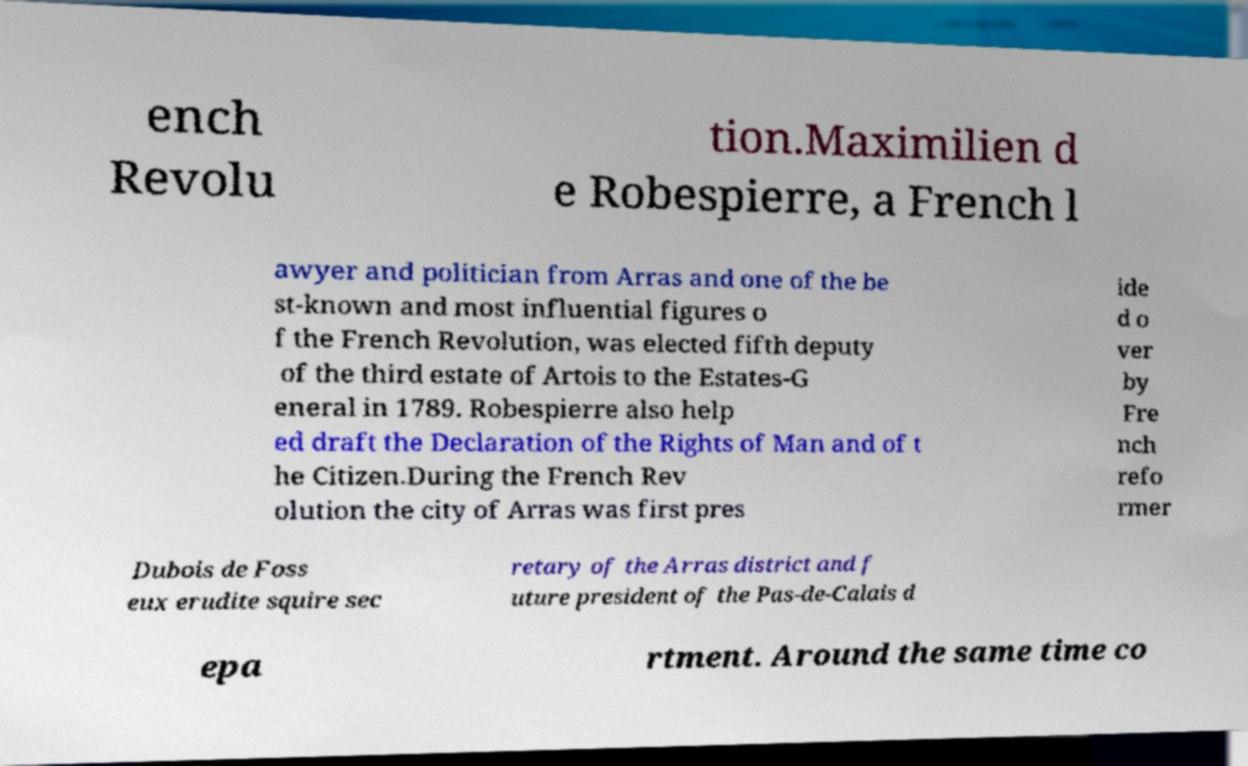There's text embedded in this image that I need extracted. Can you transcribe it verbatim? ench Revolu tion.Maximilien d e Robespierre, a French l awyer and politician from Arras and one of the be st-known and most influential figures o f the French Revolution, was elected fifth deputy of the third estate of Artois to the Estates-G eneral in 1789. Robespierre also help ed draft the Declaration of the Rights of Man and of t he Citizen.During the French Rev olution the city of Arras was first pres ide d o ver by Fre nch refo rmer Dubois de Foss eux erudite squire sec retary of the Arras district and f uture president of the Pas-de-Calais d epa rtment. Around the same time co 